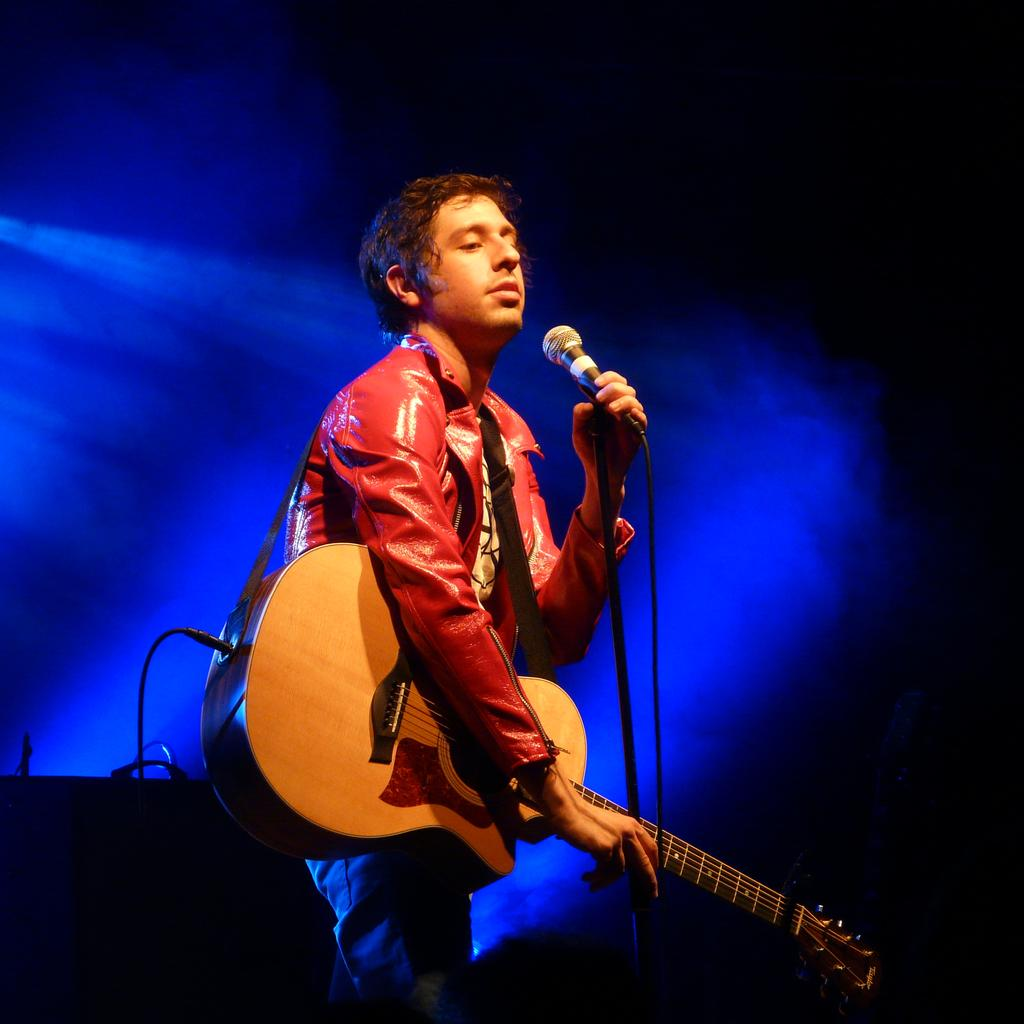What is the main subject of the image? There is a guy in the image. What is the guy doing in the image? The guy is playing a guitar. What other object can be seen in the image? There is a microphone in the image. Is the guy swimming with a chain attached to his leg in the image? No, there is no chain or swimming activity present in the image. The guy is playing a guitar and there is a microphone nearby. 